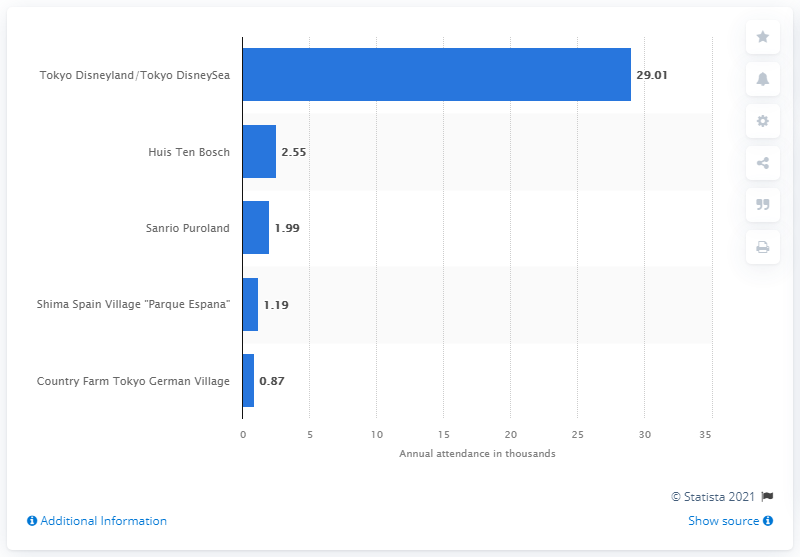Specify some key components in this picture. According to the data from the fiscal year 2020, Huis Ten Bosch was ranked as the top leading theme park in Japan. 